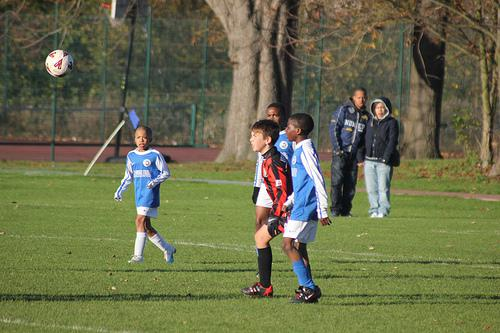Question: where was the picture taken?
Choices:
A. Polo match.
B. Weightlifting competition.
C. Soccer game.
D. Swim meet.
Answer with the letter. Answer: C Question: what are the children playing?
Choices:
A. Dodgeball.
B. Kickball.
C. Soccer.
D. Tag.
Answer with the letter. Answer: C Question: what color are the uniforms?
Choices:
A. Red and blue.
B. Pink and green.
C. Blue and white.
D. Purple and pink.
Answer with the letter. Answer: C Question: how many spectators are there?
Choices:
A. 1.
B. 5.
C. 6.
D. 2.
Answer with the letter. Answer: D Question: how many children are playing?
Choices:
A. 4.
B. 5.
C. 3.
D. 1.
Answer with the letter. Answer: A 